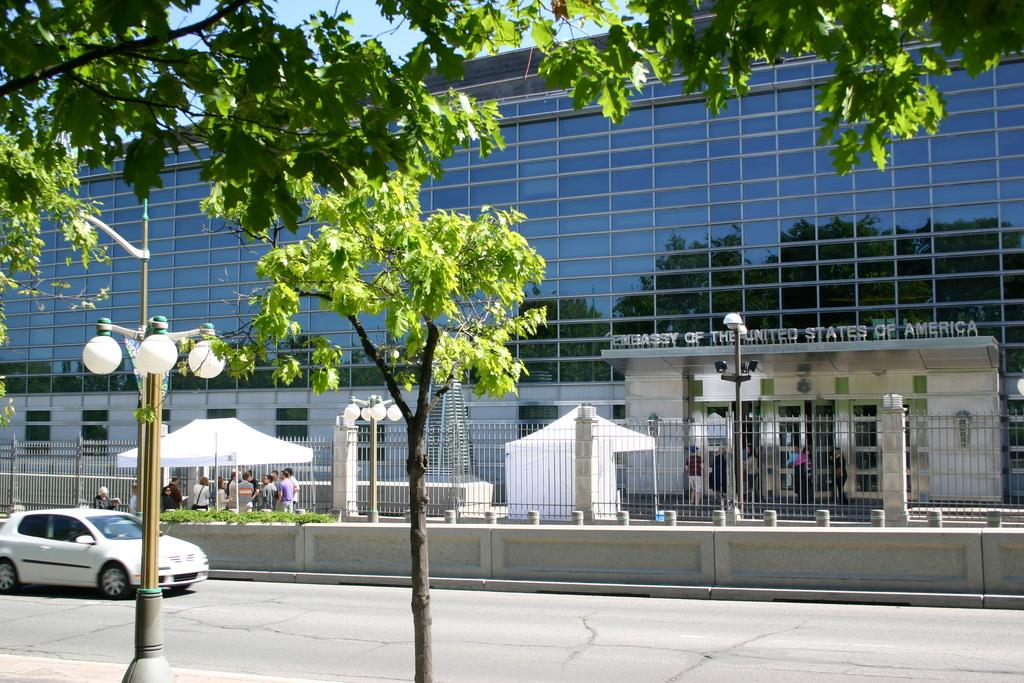What is the main subject of the image? The main subject of the image is a car on the road. What structures can be seen in the image? There are light poles, a fence, a wall, and at least one building in the image. What type of vegetation is present in the image? There are trees and grass in the image. What additional features can be seen in the image? There are tents, various objects, and people in the image. What can be seen in the background of the image? The sky is visible in the background of the image. What is the emotional condition of the car in the image? Cars do not have emotions, so it is not possible to determine their emotional condition. 